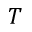Convert formula to latex. <formula><loc_0><loc_0><loc_500><loc_500>T</formula> 